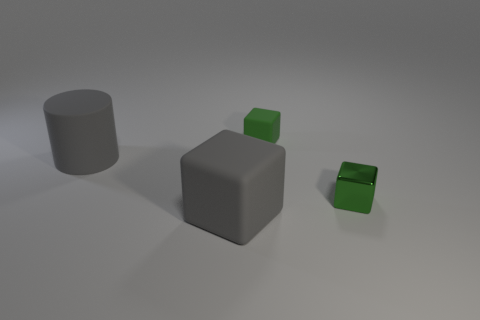How many cubes have the same size as the gray cylinder?
Give a very brief answer. 1. What number of gray things are behind the object left of the gray cube?
Your response must be concise. 0. Are the tiny cube that is to the right of the tiny rubber block and the big cylinder made of the same material?
Offer a terse response. No. Are the small green cube left of the small green shiny block and the gray object in front of the tiny metal thing made of the same material?
Give a very brief answer. Yes. Is the number of big cylinders that are to the right of the small rubber cube greater than the number of gray rubber cubes?
Your response must be concise. No. The rubber cube that is on the left side of the green thing that is behind the tiny green metallic thing is what color?
Give a very brief answer. Gray. What is the shape of the object that is the same size as the green rubber cube?
Ensure brevity in your answer.  Cube. What is the shape of the large rubber object that is the same color as the large cube?
Give a very brief answer. Cylinder. Are there an equal number of large gray blocks that are behind the green metal thing and green metallic cubes?
Give a very brief answer. No. What material is the large gray object that is to the left of the gray matte object that is in front of the small cube that is in front of the tiny rubber object made of?
Make the answer very short. Rubber. 